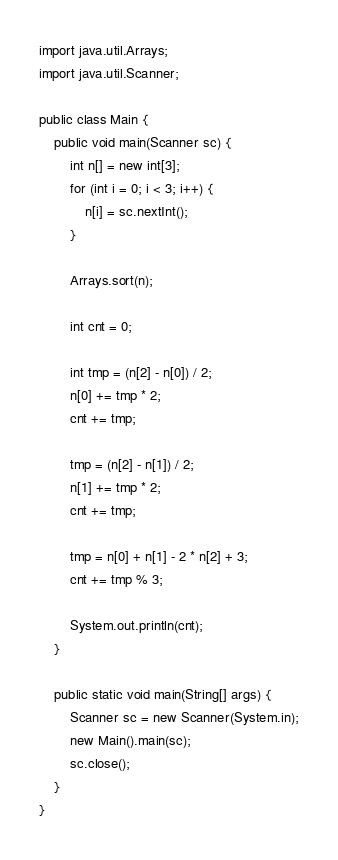Convert code to text. <code><loc_0><loc_0><loc_500><loc_500><_Java_>import java.util.Arrays;
import java.util.Scanner;

public class Main {
    public void main(Scanner sc) {
        int n[] = new int[3];
        for (int i = 0; i < 3; i++) {
            n[i] = sc.nextInt();
        }

        Arrays.sort(n);

        int cnt = 0;

        int tmp = (n[2] - n[0]) / 2;
        n[0] += tmp * 2;
        cnt += tmp;

        tmp = (n[2] - n[1]) / 2;
        n[1] += tmp * 2;
        cnt += tmp;

        tmp = n[0] + n[1] - 2 * n[2] + 3;
        cnt += tmp % 3;

        System.out.println(cnt);
    }

    public static void main(String[] args) {
        Scanner sc = new Scanner(System.in);
        new Main().main(sc);
        sc.close();
    }
}
</code> 